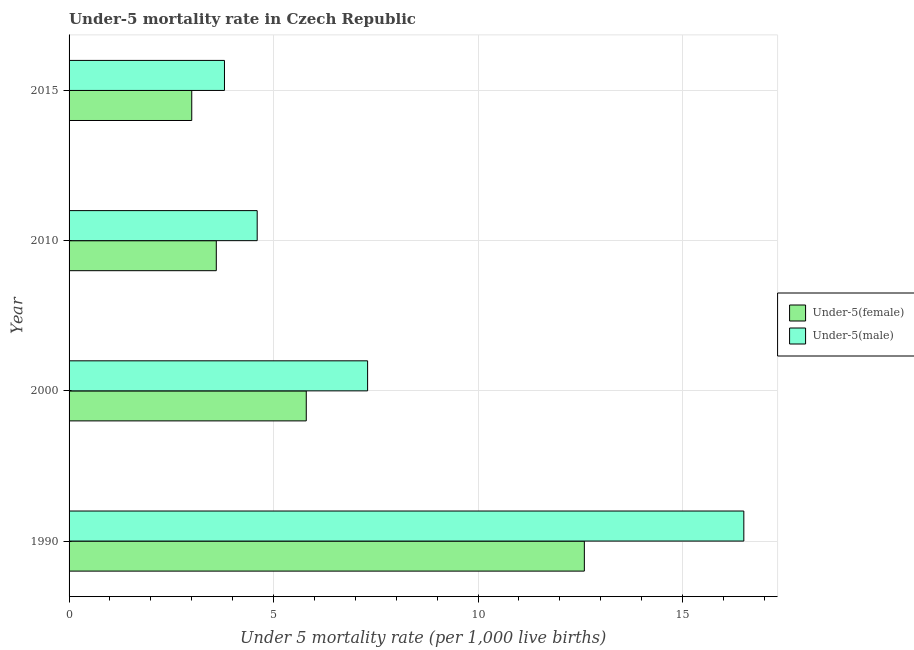How many groups of bars are there?
Offer a terse response. 4. Are the number of bars on each tick of the Y-axis equal?
Keep it short and to the point. Yes. What is the label of the 1st group of bars from the top?
Your answer should be compact. 2015. In how many cases, is the number of bars for a given year not equal to the number of legend labels?
Ensure brevity in your answer.  0. What is the under-5 female mortality rate in 2000?
Provide a short and direct response. 5.8. Across all years, what is the minimum under-5 female mortality rate?
Provide a succinct answer. 3. In which year was the under-5 female mortality rate minimum?
Provide a succinct answer. 2015. What is the difference between the under-5 female mortality rate in 2010 and that in 2015?
Your response must be concise. 0.6. What is the difference between the under-5 male mortality rate in 2010 and the under-5 female mortality rate in 2000?
Provide a succinct answer. -1.2. What is the average under-5 female mortality rate per year?
Provide a succinct answer. 6.25. In the year 2000, what is the difference between the under-5 female mortality rate and under-5 male mortality rate?
Ensure brevity in your answer.  -1.5. What is the ratio of the under-5 male mortality rate in 2010 to that in 2015?
Ensure brevity in your answer.  1.21. Is the under-5 male mortality rate in 2010 less than that in 2015?
Your answer should be very brief. No. Is the difference between the under-5 female mortality rate in 1990 and 2000 greater than the difference between the under-5 male mortality rate in 1990 and 2000?
Make the answer very short. No. What does the 1st bar from the top in 2015 represents?
Offer a terse response. Under-5(male). What does the 1st bar from the bottom in 2000 represents?
Keep it short and to the point. Under-5(female). How many bars are there?
Your response must be concise. 8. What is the difference between two consecutive major ticks on the X-axis?
Your answer should be compact. 5. Does the graph contain any zero values?
Provide a short and direct response. No. Where does the legend appear in the graph?
Give a very brief answer. Center right. How many legend labels are there?
Provide a succinct answer. 2. How are the legend labels stacked?
Keep it short and to the point. Vertical. What is the title of the graph?
Give a very brief answer. Under-5 mortality rate in Czech Republic. What is the label or title of the X-axis?
Keep it short and to the point. Under 5 mortality rate (per 1,0 live births). What is the Under 5 mortality rate (per 1,000 live births) in Under-5(female) in 1990?
Keep it short and to the point. 12.6. What is the Under 5 mortality rate (per 1,000 live births) of Under-5(male) in 2000?
Make the answer very short. 7.3. What is the Under 5 mortality rate (per 1,000 live births) of Under-5(female) in 2010?
Offer a very short reply. 3.6. What is the Under 5 mortality rate (per 1,000 live births) of Under-5(male) in 2010?
Give a very brief answer. 4.6. What is the Under 5 mortality rate (per 1,000 live births) in Under-5(female) in 2015?
Keep it short and to the point. 3. What is the Under 5 mortality rate (per 1,000 live births) of Under-5(male) in 2015?
Your response must be concise. 3.8. Across all years, what is the maximum Under 5 mortality rate (per 1,000 live births) in Under-5(male)?
Your response must be concise. 16.5. Across all years, what is the minimum Under 5 mortality rate (per 1,000 live births) in Under-5(male)?
Your answer should be very brief. 3.8. What is the total Under 5 mortality rate (per 1,000 live births) in Under-5(female) in the graph?
Offer a terse response. 25. What is the total Under 5 mortality rate (per 1,000 live births) in Under-5(male) in the graph?
Your response must be concise. 32.2. What is the difference between the Under 5 mortality rate (per 1,000 live births) in Under-5(male) in 1990 and that in 2000?
Give a very brief answer. 9.2. What is the difference between the Under 5 mortality rate (per 1,000 live births) in Under-5(female) in 1990 and that in 2010?
Offer a very short reply. 9. What is the difference between the Under 5 mortality rate (per 1,000 live births) in Under-5(female) in 1990 and that in 2015?
Make the answer very short. 9.6. What is the difference between the Under 5 mortality rate (per 1,000 live births) in Under-5(male) in 1990 and that in 2015?
Ensure brevity in your answer.  12.7. What is the difference between the Under 5 mortality rate (per 1,000 live births) of Under-5(female) in 2000 and that in 2010?
Ensure brevity in your answer.  2.2. What is the difference between the Under 5 mortality rate (per 1,000 live births) of Under-5(male) in 2000 and that in 2015?
Your answer should be very brief. 3.5. What is the difference between the Under 5 mortality rate (per 1,000 live births) in Under-5(male) in 2010 and that in 2015?
Keep it short and to the point. 0.8. What is the difference between the Under 5 mortality rate (per 1,000 live births) in Under-5(female) in 1990 and the Under 5 mortality rate (per 1,000 live births) in Under-5(male) in 2000?
Offer a terse response. 5.3. What is the difference between the Under 5 mortality rate (per 1,000 live births) in Under-5(female) in 1990 and the Under 5 mortality rate (per 1,000 live births) in Under-5(male) in 2010?
Your answer should be compact. 8. What is the difference between the Under 5 mortality rate (per 1,000 live births) of Under-5(female) in 2010 and the Under 5 mortality rate (per 1,000 live births) of Under-5(male) in 2015?
Give a very brief answer. -0.2. What is the average Under 5 mortality rate (per 1,000 live births) in Under-5(female) per year?
Ensure brevity in your answer.  6.25. What is the average Under 5 mortality rate (per 1,000 live births) in Under-5(male) per year?
Keep it short and to the point. 8.05. In the year 2000, what is the difference between the Under 5 mortality rate (per 1,000 live births) of Under-5(female) and Under 5 mortality rate (per 1,000 live births) of Under-5(male)?
Offer a terse response. -1.5. In the year 2010, what is the difference between the Under 5 mortality rate (per 1,000 live births) in Under-5(female) and Under 5 mortality rate (per 1,000 live births) in Under-5(male)?
Provide a succinct answer. -1. In the year 2015, what is the difference between the Under 5 mortality rate (per 1,000 live births) of Under-5(female) and Under 5 mortality rate (per 1,000 live births) of Under-5(male)?
Offer a terse response. -0.8. What is the ratio of the Under 5 mortality rate (per 1,000 live births) of Under-5(female) in 1990 to that in 2000?
Offer a terse response. 2.17. What is the ratio of the Under 5 mortality rate (per 1,000 live births) in Under-5(male) in 1990 to that in 2000?
Your answer should be compact. 2.26. What is the ratio of the Under 5 mortality rate (per 1,000 live births) of Under-5(female) in 1990 to that in 2010?
Your response must be concise. 3.5. What is the ratio of the Under 5 mortality rate (per 1,000 live births) of Under-5(male) in 1990 to that in 2010?
Ensure brevity in your answer.  3.59. What is the ratio of the Under 5 mortality rate (per 1,000 live births) in Under-5(male) in 1990 to that in 2015?
Provide a succinct answer. 4.34. What is the ratio of the Under 5 mortality rate (per 1,000 live births) of Under-5(female) in 2000 to that in 2010?
Provide a succinct answer. 1.61. What is the ratio of the Under 5 mortality rate (per 1,000 live births) of Under-5(male) in 2000 to that in 2010?
Provide a succinct answer. 1.59. What is the ratio of the Under 5 mortality rate (per 1,000 live births) of Under-5(female) in 2000 to that in 2015?
Provide a succinct answer. 1.93. What is the ratio of the Under 5 mortality rate (per 1,000 live births) of Under-5(male) in 2000 to that in 2015?
Your answer should be compact. 1.92. What is the ratio of the Under 5 mortality rate (per 1,000 live births) of Under-5(male) in 2010 to that in 2015?
Your response must be concise. 1.21. What is the difference between the highest and the second highest Under 5 mortality rate (per 1,000 live births) of Under-5(female)?
Keep it short and to the point. 6.8. What is the difference between the highest and the second highest Under 5 mortality rate (per 1,000 live births) in Under-5(male)?
Offer a very short reply. 9.2. What is the difference between the highest and the lowest Under 5 mortality rate (per 1,000 live births) of Under-5(male)?
Your answer should be compact. 12.7. 